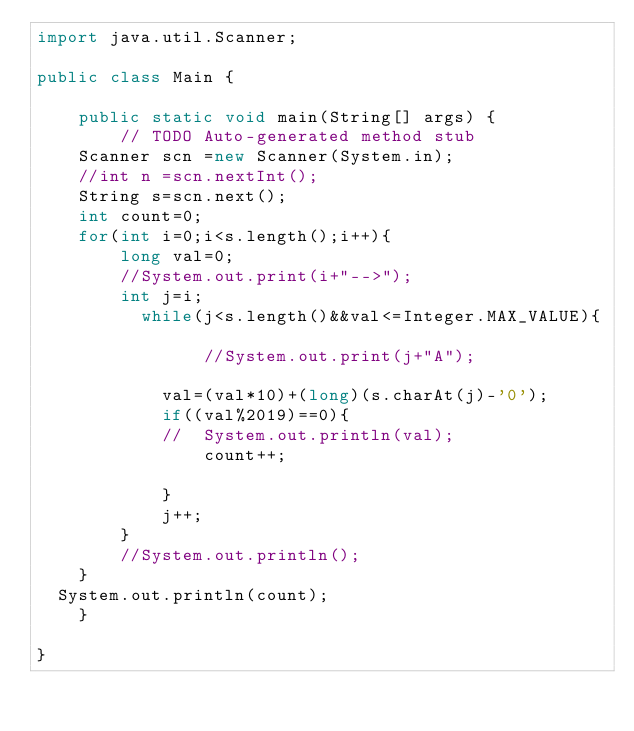Convert code to text. <code><loc_0><loc_0><loc_500><loc_500><_Java_>import java.util.Scanner;

public class Main {

	public static void main(String[] args) {
		// TODO Auto-generated method stub
	Scanner scn =new Scanner(System.in);
	//int n =scn.nextInt();
	String s=scn.next();
	int count=0;
	for(int i=0;i<s.length();i++){
		long val=0;
		//System.out.print(i+"-->");
		int j=i;
		  while(j<s.length()&&val<=Integer.MAX_VALUE){
			
				//System.out.print(j+"A");
		
			val=(val*10)+(long)(s.charAt(j)-'0');
			if((val%2019)==0){
			//	System.out.println(val);
				count++;
				
			}
			j++;
		}
		//System.out.println();
	}
  System.out.println(count);
	}

}</code> 